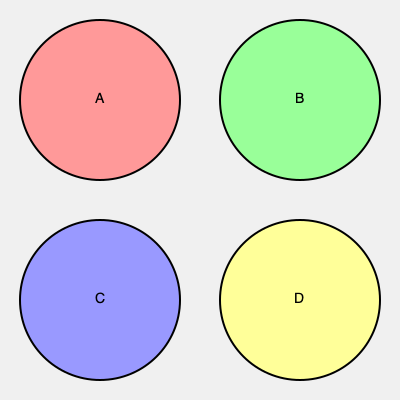Analyze the confocal microscopy images (A-D) of stem cells stained for different markers. Which image likely represents pluripotent stem cells expressing high levels of Oct4 and displaying a typical compact colony morphology? To determine which image represents pluripotent stem cells with high Oct4 expression and typical colony morphology, we need to consider the following:

1. Pluripotent stem cell morphology:
   - Typically form compact, round colonies with defined edges
   - Cells within colonies are small and tightly packed

2. Oct4 expression:
   - Oct4 is a key pluripotency marker
   - High expression would result in strong, uniform staining

3. Analysis of images:
   A: Shows a compact, round colony with uniform staining
   B: Displays scattered, elongated cells with weak staining
   C: Exhibits loosely arranged cells with moderate staining
   D: Shows irregularly shaped cells with non-uniform staining

4. Conclusion:
   Image A best represents pluripotent stem cells due to:
   - Compact, round colony morphology
   - Strong, uniform staining indicating high Oct4 expression
   - Small, tightly packed cells within the colony
Answer: A 